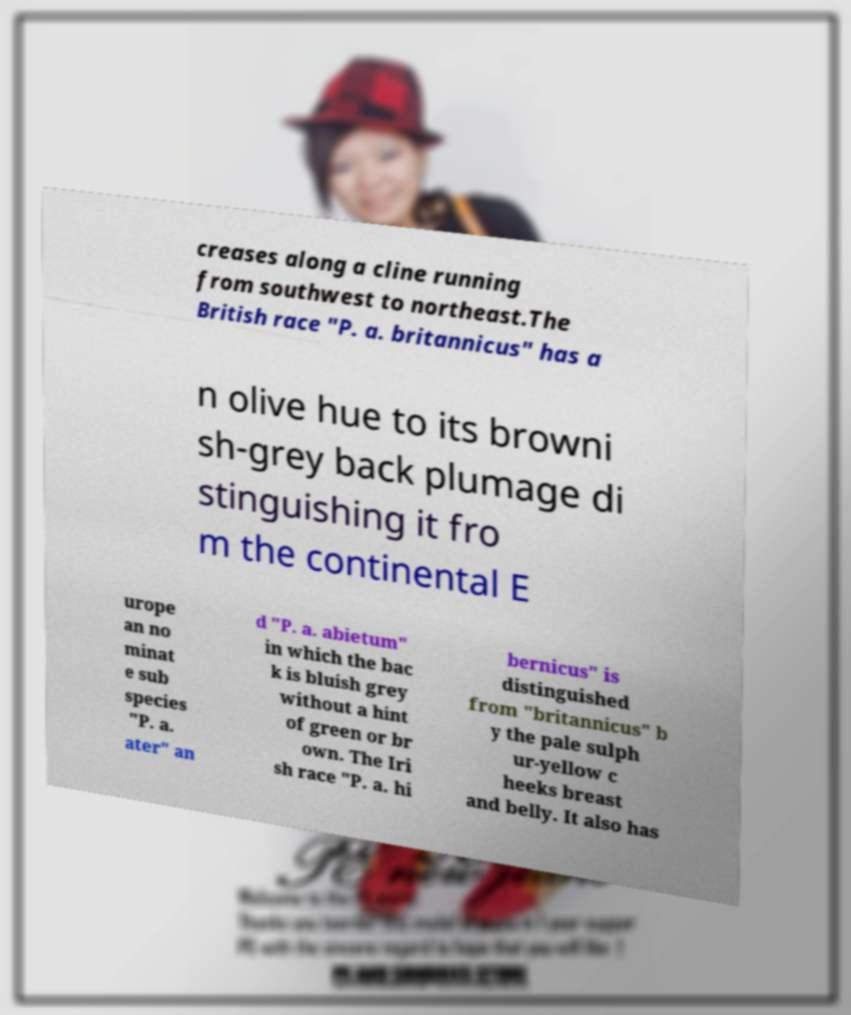I need the written content from this picture converted into text. Can you do that? creases along a cline running from southwest to northeast.The British race "P. a. britannicus" has a n olive hue to its browni sh-grey back plumage di stinguishing it fro m the continental E urope an no minat e sub species "P. a. ater" an d "P. a. abietum" in which the bac k is bluish grey without a hint of green or br own. The Iri sh race "P. a. hi bernicus" is distinguished from "britannicus" b y the pale sulph ur-yellow c heeks breast and belly. It also has 